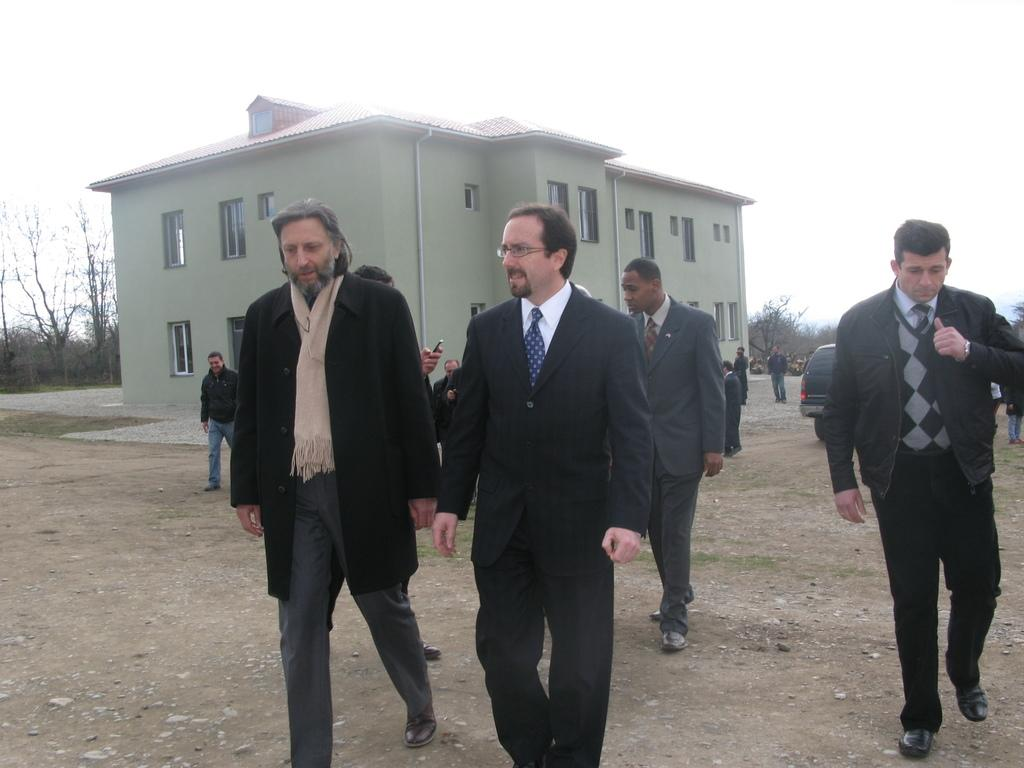What are the people in the image doing? People are walking in the image. What type of clothing can be seen on some of the people? Some people are wearing suits. What can be seen in the distance in the image? There is a building, a vehicle, and trees in the background of the image. How many balloons are tied to the nest in the image? There is no nest or balloons present in the image. What is the limit of the people walking in the image? There is no specific limit mentioned for the people walking in the image. 